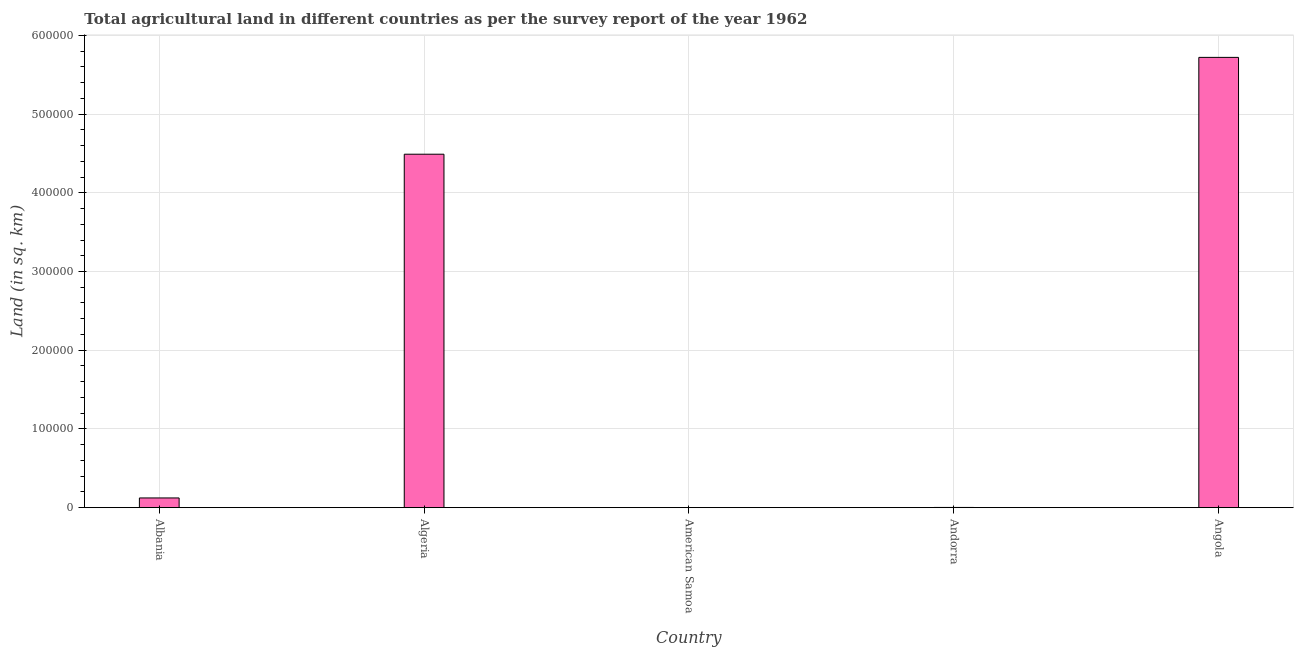Does the graph contain grids?
Give a very brief answer. Yes. What is the title of the graph?
Provide a succinct answer. Total agricultural land in different countries as per the survey report of the year 1962. What is the label or title of the X-axis?
Make the answer very short. Country. What is the label or title of the Y-axis?
Give a very brief answer. Land (in sq. km). What is the agricultural land in Algeria?
Offer a terse response. 4.49e+05. Across all countries, what is the maximum agricultural land?
Ensure brevity in your answer.  5.72e+05. In which country was the agricultural land maximum?
Provide a succinct answer. Angola. In which country was the agricultural land minimum?
Give a very brief answer. American Samoa. What is the sum of the agricultural land?
Give a very brief answer. 1.03e+06. What is the difference between the agricultural land in American Samoa and Andorra?
Provide a short and direct response. -230. What is the average agricultural land per country?
Give a very brief answer. 2.07e+05. What is the median agricultural land?
Your answer should be very brief. 1.23e+04. What is the ratio of the agricultural land in Albania to that in Angola?
Provide a succinct answer. 0.02. Is the difference between the agricultural land in Albania and Algeria greater than the difference between any two countries?
Offer a very short reply. No. What is the difference between the highest and the second highest agricultural land?
Provide a succinct answer. 1.23e+05. What is the difference between the highest and the lowest agricultural land?
Provide a short and direct response. 5.72e+05. Are all the bars in the graph horizontal?
Offer a terse response. No. How many countries are there in the graph?
Your response must be concise. 5. Are the values on the major ticks of Y-axis written in scientific E-notation?
Provide a succinct answer. No. What is the Land (in sq. km) in Albania?
Provide a succinct answer. 1.23e+04. What is the Land (in sq. km) of Algeria?
Keep it short and to the point. 4.49e+05. What is the Land (in sq. km) of American Samoa?
Provide a succinct answer. 30. What is the Land (in sq. km) in Andorra?
Keep it short and to the point. 260. What is the Land (in sq. km) in Angola?
Ensure brevity in your answer.  5.72e+05. What is the difference between the Land (in sq. km) in Albania and Algeria?
Your answer should be compact. -4.37e+05. What is the difference between the Land (in sq. km) in Albania and American Samoa?
Provide a succinct answer. 1.23e+04. What is the difference between the Land (in sq. km) in Albania and Andorra?
Offer a terse response. 1.21e+04. What is the difference between the Land (in sq. km) in Albania and Angola?
Your response must be concise. -5.60e+05. What is the difference between the Land (in sq. km) in Algeria and American Samoa?
Provide a succinct answer. 4.49e+05. What is the difference between the Land (in sq. km) in Algeria and Andorra?
Your response must be concise. 4.49e+05. What is the difference between the Land (in sq. km) in Algeria and Angola?
Your answer should be very brief. -1.23e+05. What is the difference between the Land (in sq. km) in American Samoa and Andorra?
Offer a very short reply. -230. What is the difference between the Land (in sq. km) in American Samoa and Angola?
Offer a terse response. -5.72e+05. What is the difference between the Land (in sq. km) in Andorra and Angola?
Give a very brief answer. -5.72e+05. What is the ratio of the Land (in sq. km) in Albania to that in Algeria?
Your response must be concise. 0.03. What is the ratio of the Land (in sq. km) in Albania to that in American Samoa?
Your answer should be very brief. 410.67. What is the ratio of the Land (in sq. km) in Albania to that in Andorra?
Your answer should be compact. 47.38. What is the ratio of the Land (in sq. km) in Albania to that in Angola?
Keep it short and to the point. 0.02. What is the ratio of the Land (in sq. km) in Algeria to that in American Samoa?
Make the answer very short. 1.50e+04. What is the ratio of the Land (in sq. km) in Algeria to that in Andorra?
Keep it short and to the point. 1726.92. What is the ratio of the Land (in sq. km) in Algeria to that in Angola?
Give a very brief answer. 0.79. What is the ratio of the Land (in sq. km) in American Samoa to that in Andorra?
Ensure brevity in your answer.  0.12. What is the ratio of the Land (in sq. km) in Andorra to that in Angola?
Your answer should be compact. 0. 